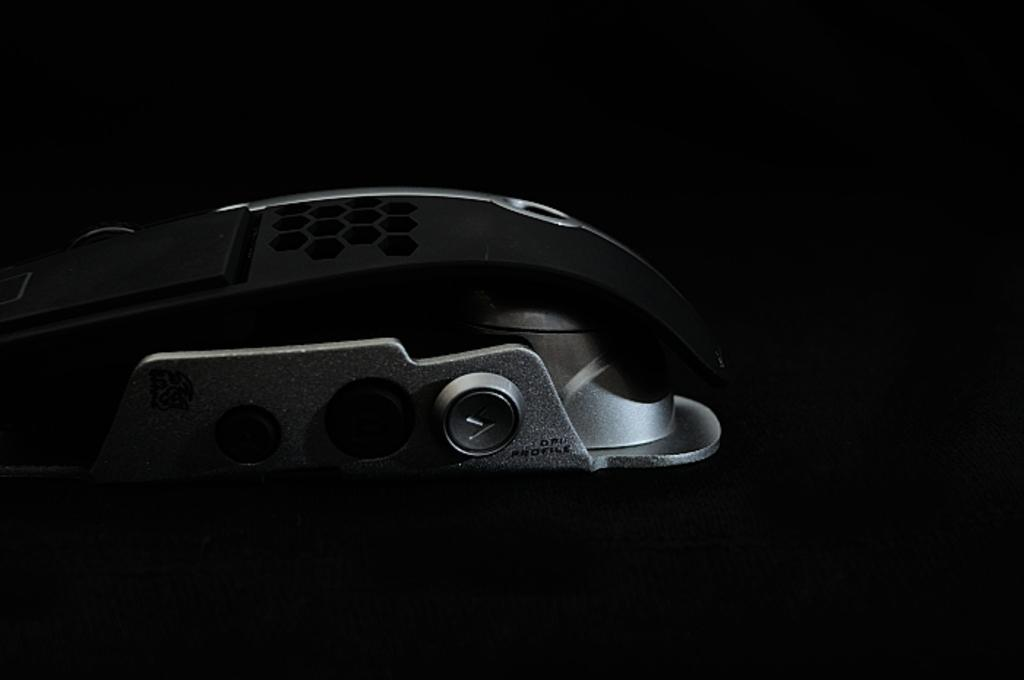What is the overall lighting condition in the image? The image has a dark view. What can be seen in the middle of the image? There is an object visible in the middle of the image. What type of knowledge is being shared at the airport in the image? There is no airport or knowledge sharing present in the image; it has a dark view with an object in the middle. 